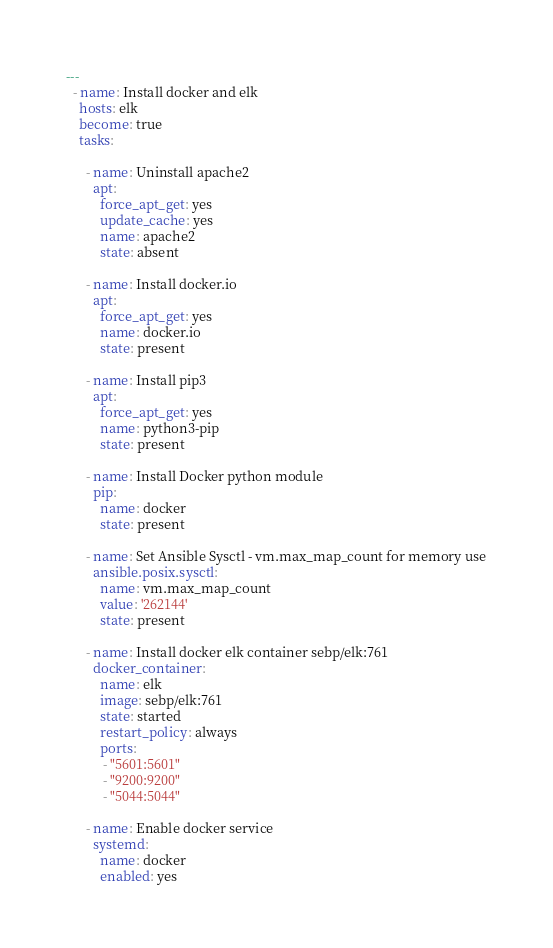<code> <loc_0><loc_0><loc_500><loc_500><_YAML_>---
  - name: Install docker and elk
    hosts: elk
    become: true
    tasks:

      - name: Uninstall apache2
        apt:
          force_apt_get: yes
          update_cache: yes
          name: apache2
          state: absent

      - name: Install docker.io
        apt:
          force_apt_get: yes
          name: docker.io
          state: present

      - name: Install pip3
        apt:
          force_apt_get: yes
          name: python3-pip
          state: present

      - name: Install Docker python module
        pip:
          name: docker
          state: present

      - name: Set Ansible Sysctl - vm.max_map_count for memory use
        ansible.posix.sysctl:
          name: vm.max_map_count
          value: '262144'
          state: present

      - name: Install docker elk container sebp/elk:761
        docker_container:
          name: elk
          image: sebp/elk:761
          state: started
          restart_policy: always
          ports:
           - "5601:5601"
           - "9200:9200"
           - "5044:5044"

      - name: Enable docker service
        systemd:
          name: docker
          enabled: yes
</code> 